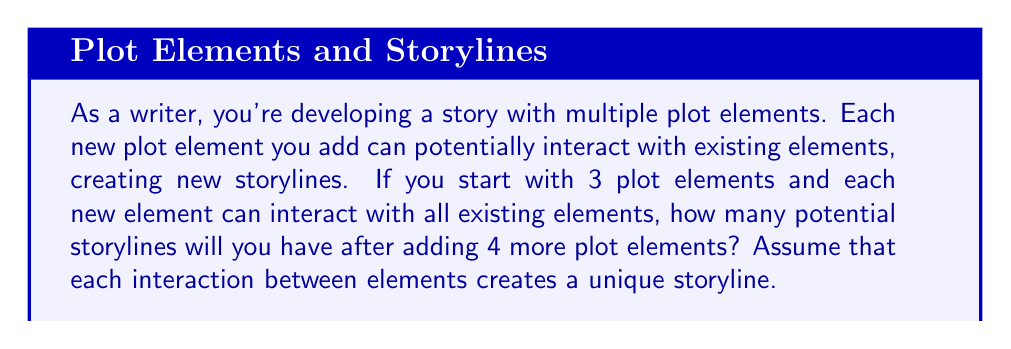Solve this math problem. Let's approach this step-by-step:

1) We start with 3 plot elements.

2) Each new element can interact with all existing elements, including itself. This means the number of potential storylines increases exponentially.

3) The formula for this scenario is:

   $$S_n = 2^n - 1$$

   Where $S_n$ is the number of potential storylines, and $n$ is the total number of plot elements.

4) We're adding 4 more elements to the initial 3, so our final $n$ is 7.

5) Let's plug this into our formula:

   $$S_7 = 2^7 - 1$$

6) Now, let's calculate:

   $$S_7 = 128 - 1 = 127$$

This exponential growth demonstrates how quickly story complexity can increase with each added plot element, highlighting the challenge and opportunity for writers in managing and leveraging these interactions to create rich, layered narratives.
Answer: 127 potential storylines 